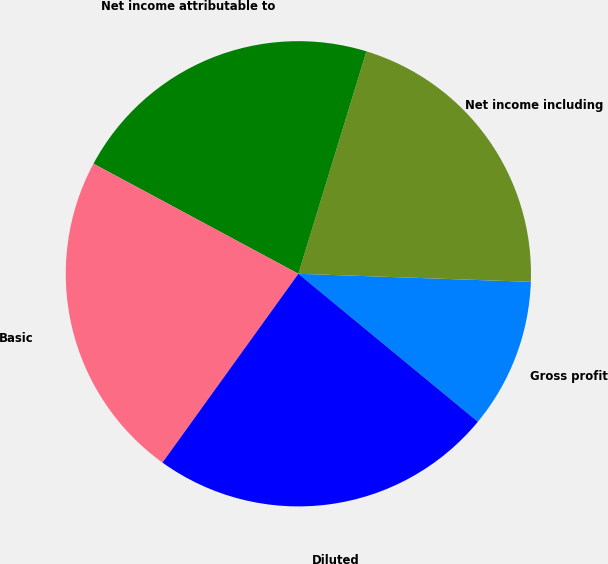Convert chart. <chart><loc_0><loc_0><loc_500><loc_500><pie_chart><fcel>Gross profit<fcel>Net income including<fcel>Net income attributable to<fcel>Basic<fcel>Diluted<nl><fcel>10.42%<fcel>20.83%<fcel>21.88%<fcel>22.92%<fcel>23.96%<nl></chart> 